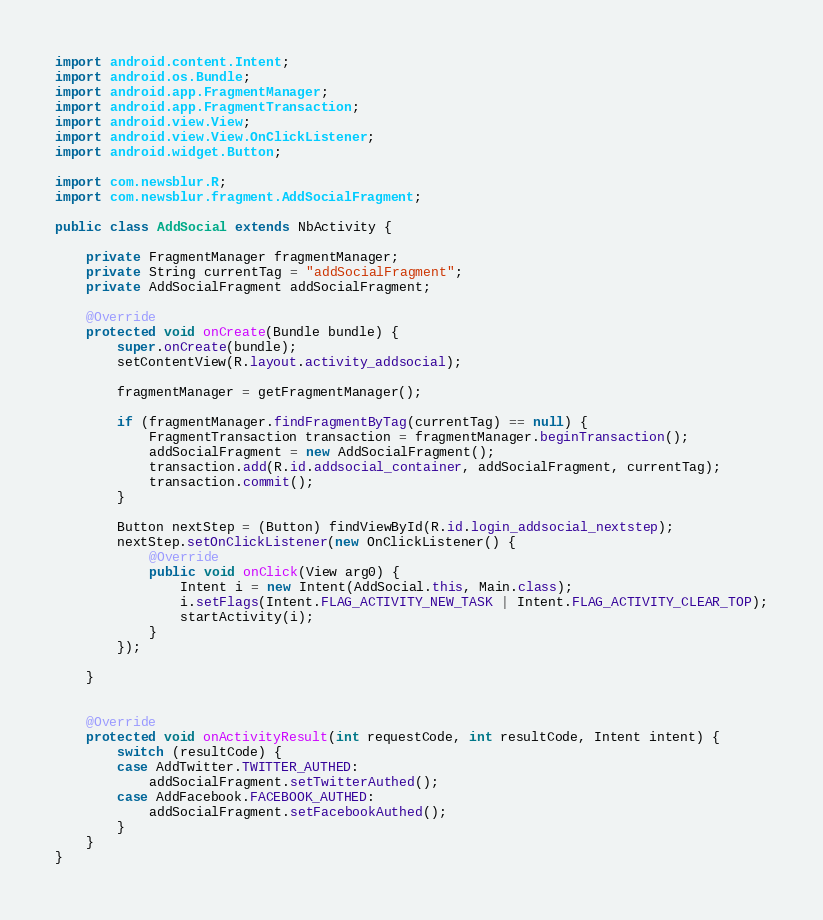Convert code to text. <code><loc_0><loc_0><loc_500><loc_500><_Java_>
import android.content.Intent;
import android.os.Bundle;
import android.app.FragmentManager;
import android.app.FragmentTransaction;
import android.view.View;
import android.view.View.OnClickListener;
import android.widget.Button;

import com.newsblur.R;
import com.newsblur.fragment.AddSocialFragment;

public class AddSocial extends NbActivity {

	private FragmentManager fragmentManager;
	private String currentTag = "addSocialFragment";
	private AddSocialFragment addSocialFragment;

	@Override
	protected void onCreate(Bundle bundle) {
		super.onCreate(bundle);
		setContentView(R.layout.activity_addsocial);
		
		fragmentManager = getFragmentManager();

		if (fragmentManager.findFragmentByTag(currentTag) == null) {
			FragmentTransaction transaction = fragmentManager.beginTransaction();
			addSocialFragment = new AddSocialFragment();
			transaction.add(R.id.addsocial_container, addSocialFragment, currentTag);
			transaction.commit();
		}
		
		Button nextStep = (Button) findViewById(R.id.login_addsocial_nextstep);
		nextStep.setOnClickListener(new OnClickListener() {
			@Override
			public void onClick(View arg0) {
                Intent i = new Intent(AddSocial.this, Main.class);
                i.setFlags(Intent.FLAG_ACTIVITY_NEW_TASK | Intent.FLAG_ACTIVITY_CLEAR_TOP);
                startActivity(i);
			}
		});
		
	}
	
	
	@Override
	protected void onActivityResult(int requestCode, int resultCode, Intent intent) {
		switch (resultCode) {
		case AddTwitter.TWITTER_AUTHED:
			addSocialFragment.setTwitterAuthed();
		case AddFacebook.FACEBOOK_AUTHED:
			addSocialFragment.setFacebookAuthed();	
		}
	}
}
</code> 